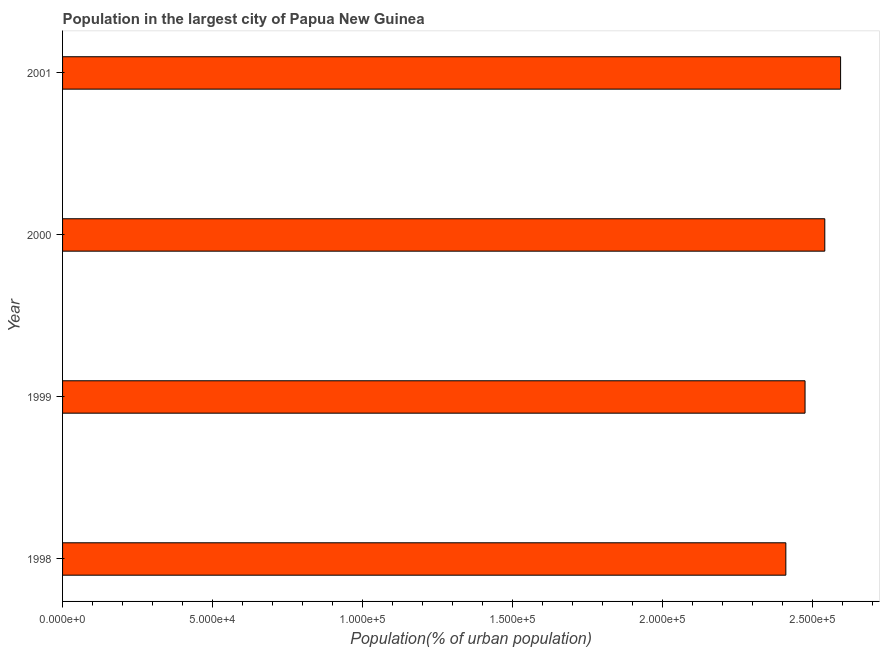Does the graph contain any zero values?
Give a very brief answer. No. What is the title of the graph?
Offer a very short reply. Population in the largest city of Papua New Guinea. What is the label or title of the X-axis?
Offer a terse response. Population(% of urban population). What is the population in largest city in 1999?
Offer a very short reply. 2.47e+05. Across all years, what is the maximum population in largest city?
Make the answer very short. 2.59e+05. Across all years, what is the minimum population in largest city?
Ensure brevity in your answer.  2.41e+05. What is the sum of the population in largest city?
Your answer should be compact. 1.00e+06. What is the difference between the population in largest city in 1998 and 2000?
Your answer should be very brief. -1.30e+04. What is the average population in largest city per year?
Ensure brevity in your answer.  2.50e+05. What is the median population in largest city?
Your answer should be compact. 2.51e+05. What is the ratio of the population in largest city in 1999 to that in 2001?
Offer a terse response. 0.95. Is the difference between the population in largest city in 1999 and 2000 greater than the difference between any two years?
Ensure brevity in your answer.  No. What is the difference between the highest and the second highest population in largest city?
Offer a very short reply. 5263. Is the sum of the population in largest city in 2000 and 2001 greater than the maximum population in largest city across all years?
Offer a terse response. Yes. What is the difference between the highest and the lowest population in largest city?
Ensure brevity in your answer.  1.82e+04. In how many years, is the population in largest city greater than the average population in largest city taken over all years?
Your response must be concise. 2. How many bars are there?
Ensure brevity in your answer.  4. Are all the bars in the graph horizontal?
Your response must be concise. Yes. How many years are there in the graph?
Keep it short and to the point. 4. What is the difference between two consecutive major ticks on the X-axis?
Provide a succinct answer. 5.00e+04. Are the values on the major ticks of X-axis written in scientific E-notation?
Your answer should be compact. Yes. What is the Population(% of urban population) of 1998?
Offer a terse response. 2.41e+05. What is the Population(% of urban population) in 1999?
Offer a terse response. 2.47e+05. What is the Population(% of urban population) of 2000?
Keep it short and to the point. 2.54e+05. What is the Population(% of urban population) in 2001?
Provide a short and direct response. 2.59e+05. What is the difference between the Population(% of urban population) in 1998 and 1999?
Give a very brief answer. -6402. What is the difference between the Population(% of urban population) in 1998 and 2000?
Ensure brevity in your answer.  -1.30e+04. What is the difference between the Population(% of urban population) in 1998 and 2001?
Your answer should be compact. -1.82e+04. What is the difference between the Population(% of urban population) in 1999 and 2000?
Offer a terse response. -6581. What is the difference between the Population(% of urban population) in 1999 and 2001?
Your response must be concise. -1.18e+04. What is the difference between the Population(% of urban population) in 2000 and 2001?
Make the answer very short. -5263. What is the ratio of the Population(% of urban population) in 1998 to that in 1999?
Ensure brevity in your answer.  0.97. What is the ratio of the Population(% of urban population) in 1998 to that in 2000?
Make the answer very short. 0.95. What is the ratio of the Population(% of urban population) in 1999 to that in 2000?
Your answer should be very brief. 0.97. What is the ratio of the Population(% of urban population) in 1999 to that in 2001?
Your response must be concise. 0.95. What is the ratio of the Population(% of urban population) in 2000 to that in 2001?
Keep it short and to the point. 0.98. 